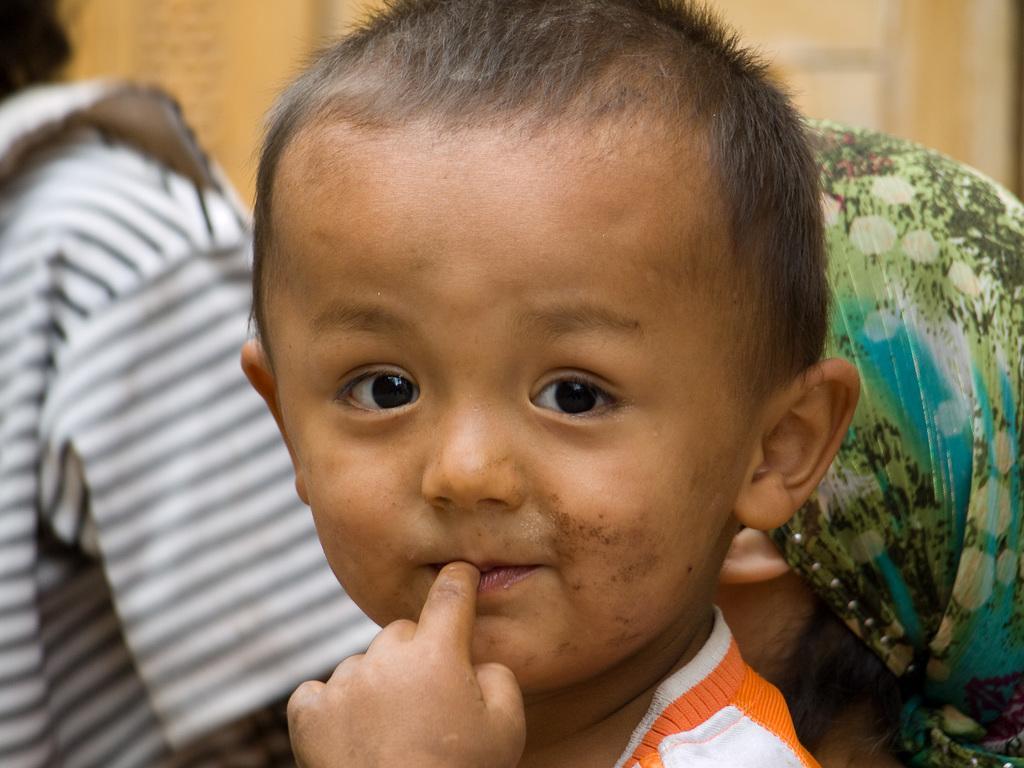Describe this image in one or two sentences. There is a small kid. In the back there are two persons. Person on the right is wearing a scarf on the head. In the background it is blurred. 